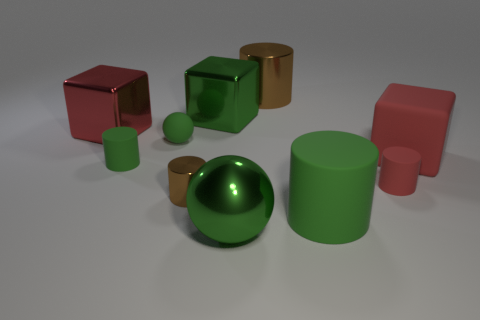Subtract all red cubes. How many cubes are left? 1 Subtract 1 blocks. How many blocks are left? 2 Subtract all spheres. How many objects are left? 8 Subtract all brown cylinders. How many cylinders are left? 3 Subtract all tiny gray rubber spheres. Subtract all big red matte objects. How many objects are left? 9 Add 5 small brown things. How many small brown things are left? 6 Add 4 rubber things. How many rubber things exist? 9 Subtract 0 cyan spheres. How many objects are left? 10 Subtract all blue blocks. Subtract all brown balls. How many blocks are left? 3 Subtract all cyan blocks. How many brown cylinders are left? 2 